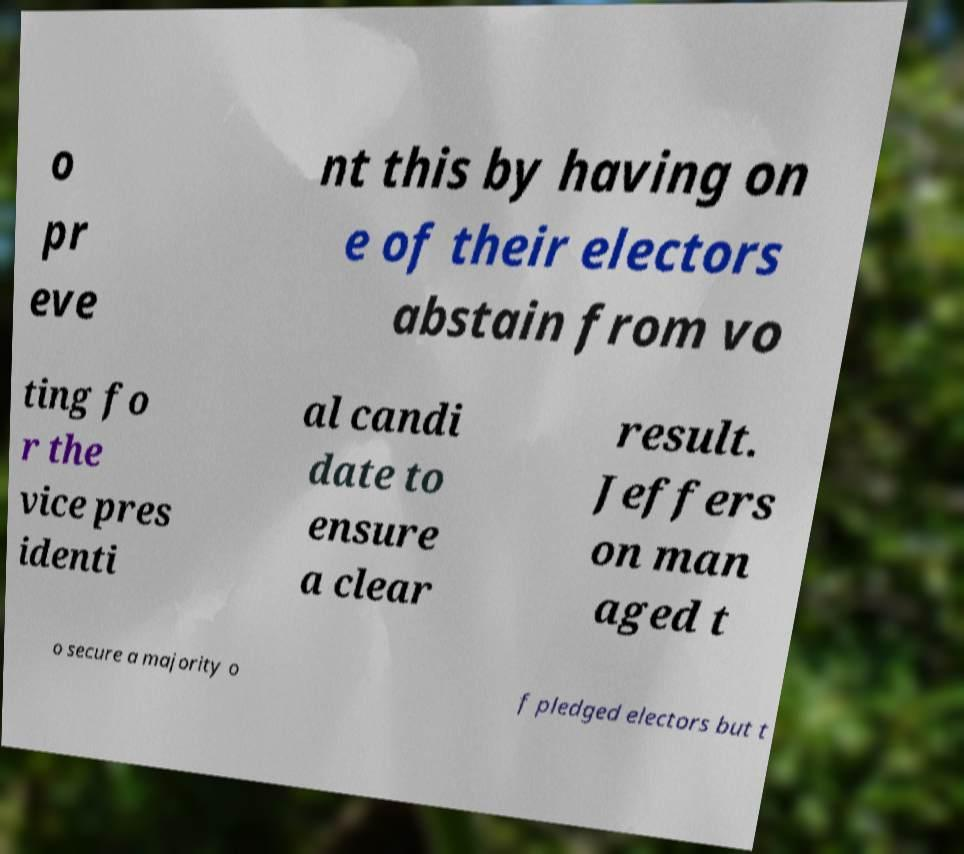Could you assist in decoding the text presented in this image and type it out clearly? o pr eve nt this by having on e of their electors abstain from vo ting fo r the vice pres identi al candi date to ensure a clear result. Jeffers on man aged t o secure a majority o f pledged electors but t 